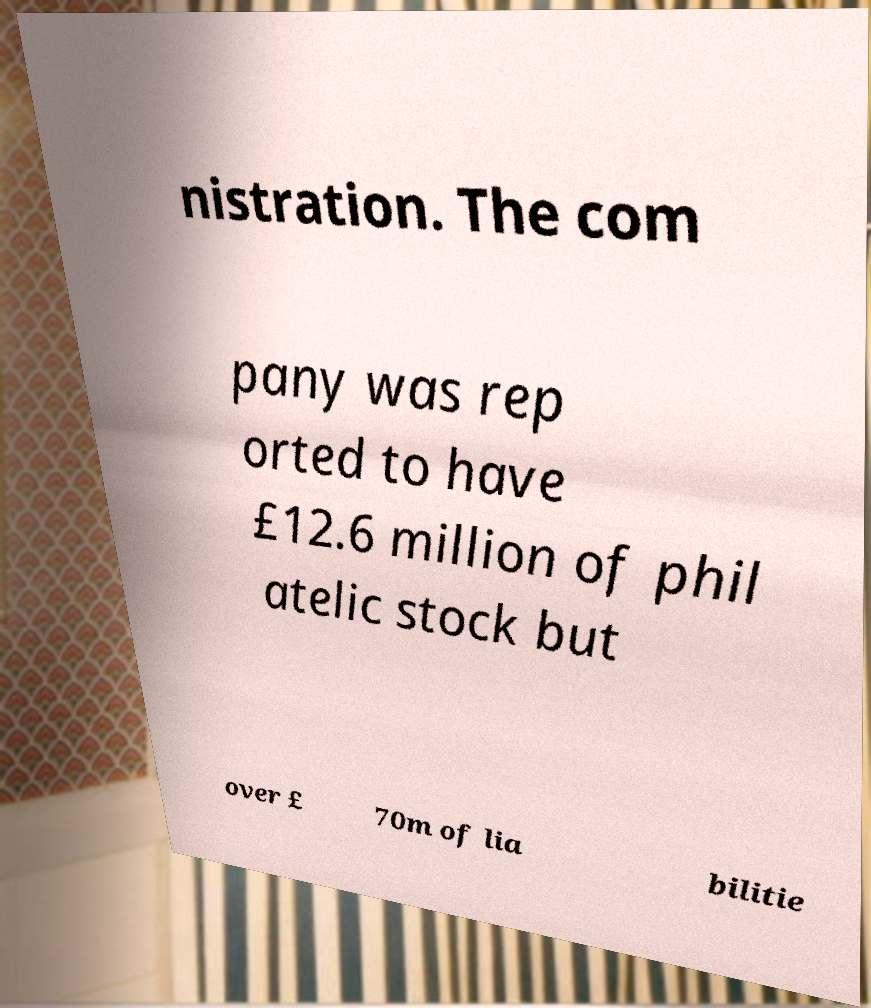There's text embedded in this image that I need extracted. Can you transcribe it verbatim? nistration. The com pany was rep orted to have £12.6 million of phil atelic stock but over £ 70m of lia bilitie 